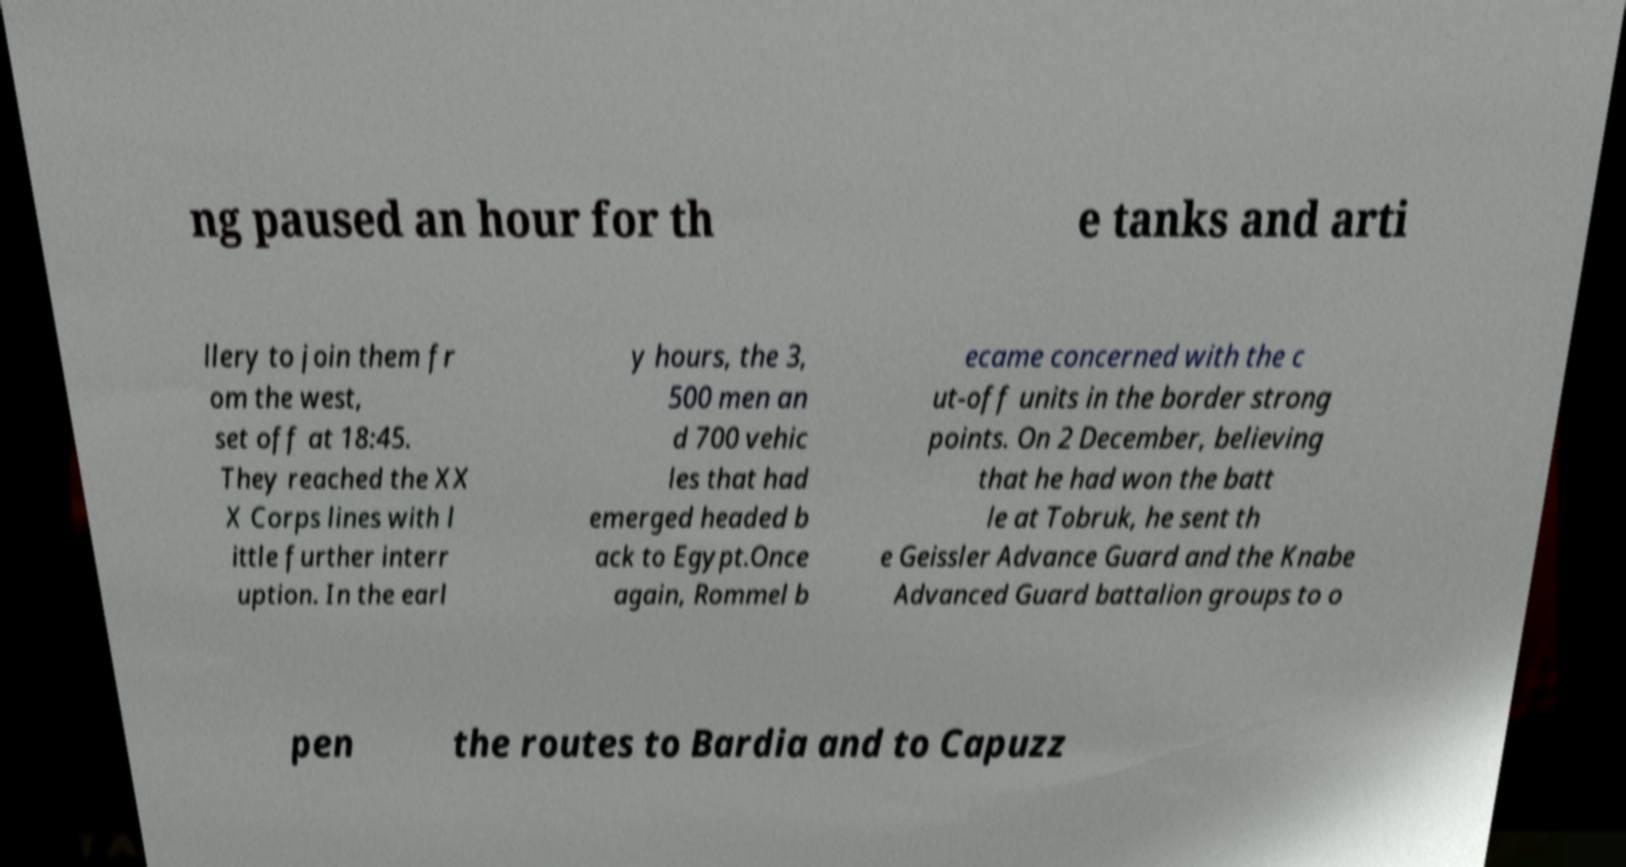For documentation purposes, I need the text within this image transcribed. Could you provide that? ng paused an hour for th e tanks and arti llery to join them fr om the west, set off at 18:45. They reached the XX X Corps lines with l ittle further interr uption. In the earl y hours, the 3, 500 men an d 700 vehic les that had emerged headed b ack to Egypt.Once again, Rommel b ecame concerned with the c ut-off units in the border strong points. On 2 December, believing that he had won the batt le at Tobruk, he sent th e Geissler Advance Guard and the Knabe Advanced Guard battalion groups to o pen the routes to Bardia and to Capuzz 